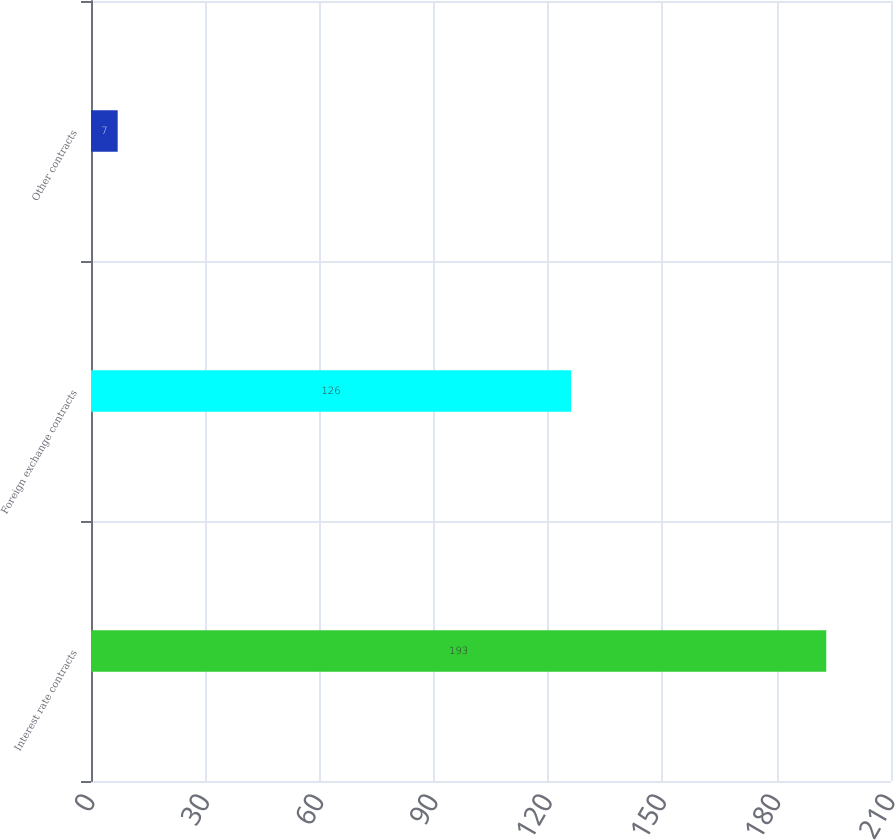<chart> <loc_0><loc_0><loc_500><loc_500><bar_chart><fcel>Interest rate contracts<fcel>Foreign exchange contracts<fcel>Other contracts<nl><fcel>193<fcel>126<fcel>7<nl></chart> 